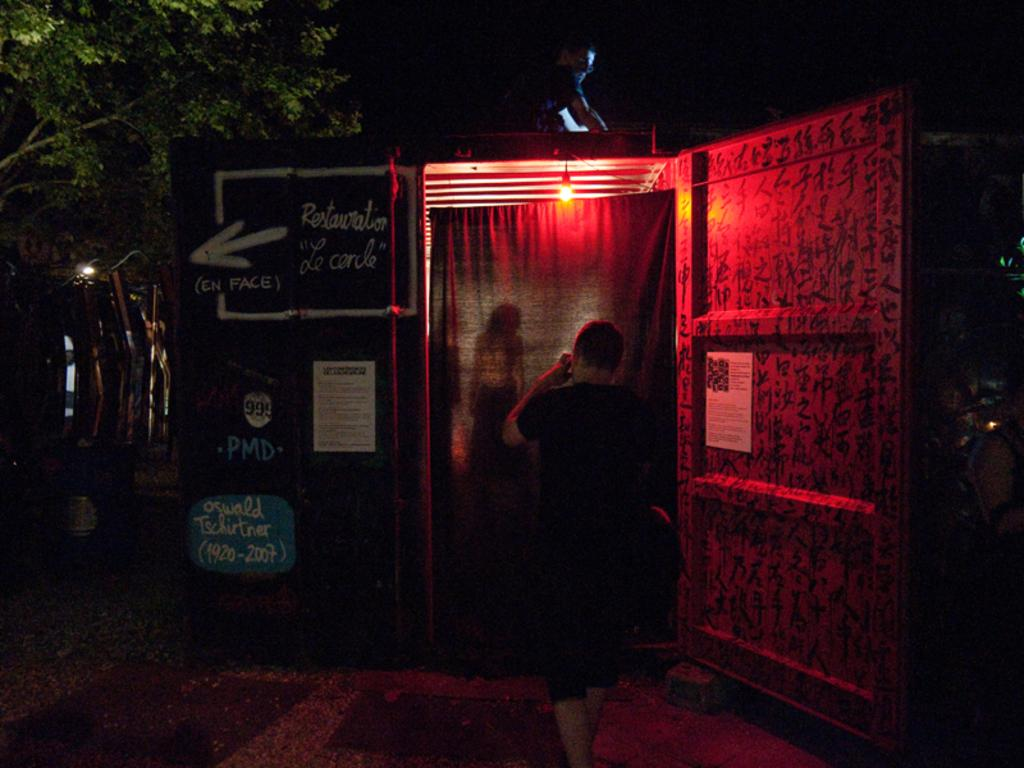What is the person at the door doing in the image? There is a person standing at the door in the image. What can be seen hanging near the door? There is a curtain in the image. What can be seen in the background of the image? Trees are present in the image. What is the source of light in the image? There is light visible in the image. Where is the other person located in the image? There is a person on the roof in the image. What type of fog can be seen in the image? There is no fog present in the image. 